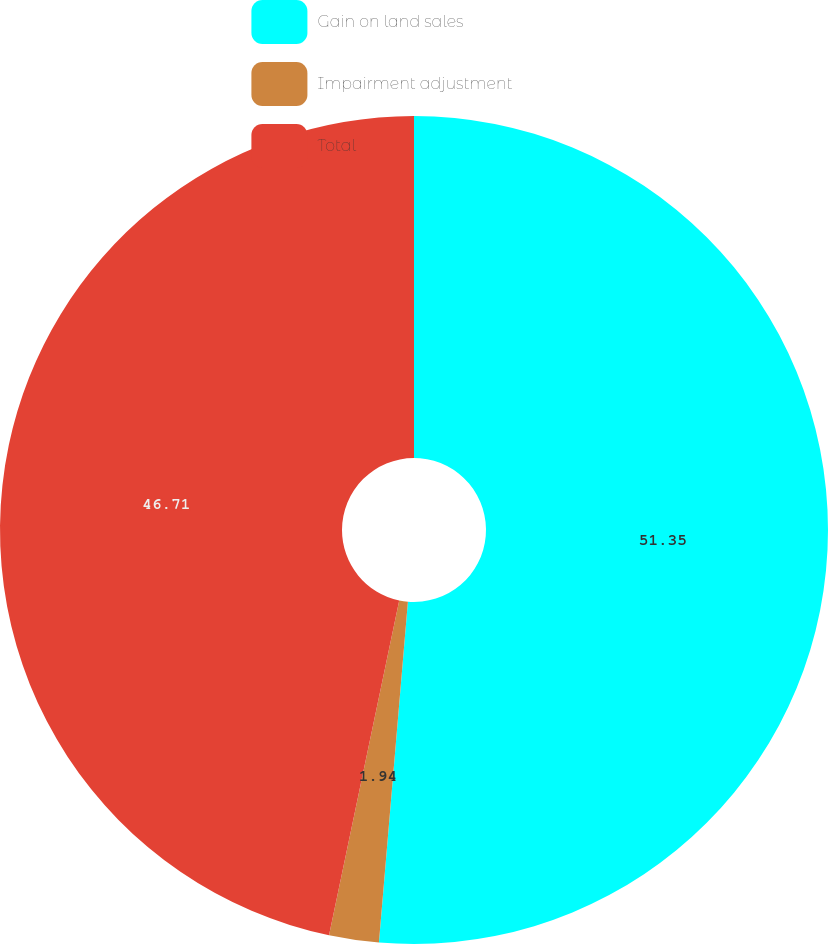Convert chart. <chart><loc_0><loc_0><loc_500><loc_500><pie_chart><fcel>Gain on land sales<fcel>Impairment adjustment<fcel>Total<nl><fcel>51.35%<fcel>1.94%<fcel>46.71%<nl></chart> 